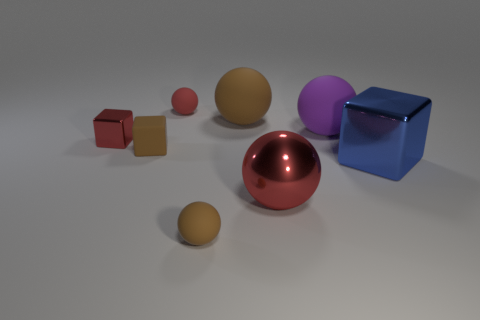Subtract all large purple rubber spheres. How many spheres are left? 4 Subtract all blocks. How many objects are left? 5 Add 1 red matte blocks. How many objects exist? 9 Subtract all brown blocks. How many blocks are left? 2 Subtract 0 cyan cylinders. How many objects are left? 8 Subtract 5 balls. How many balls are left? 0 Subtract all green blocks. Subtract all blue cylinders. How many blocks are left? 3 Subtract all cyan balls. How many brown blocks are left? 1 Subtract all big red balls. Subtract all brown matte things. How many objects are left? 4 Add 8 tiny red metallic things. How many tiny red metallic things are left? 9 